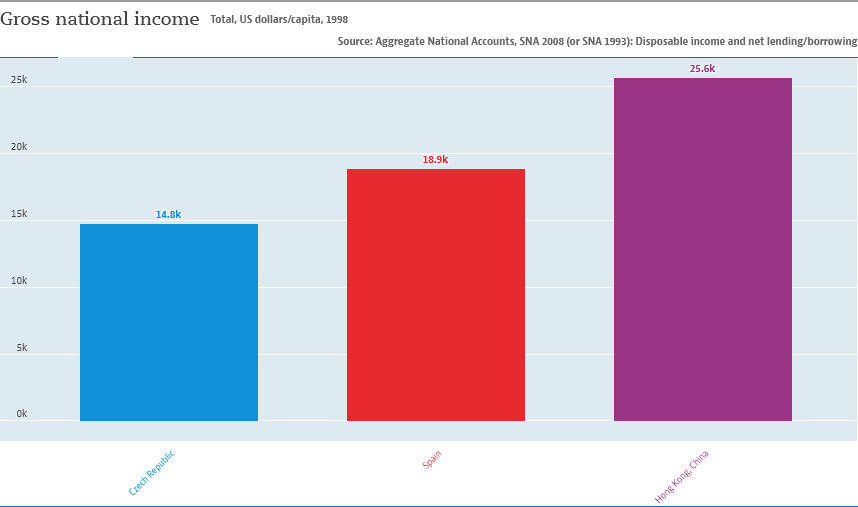Specify some key components in this picture. The light blue color bar denotes the Czech Republic. The average of the two smallest bars is 16.85. 